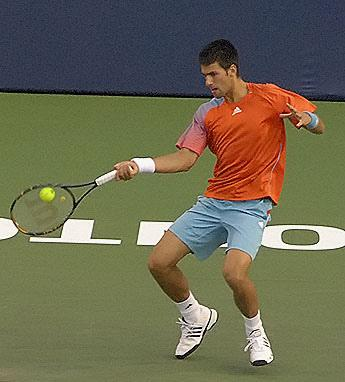Count the number of visible tennis balls and tennis rackets in the picture. There is one tennis ball and one tennis racket visible in the image. What is the color of the tennis ball shown in the picture, and what is its current action? The tennis ball is neon green or yellow-green and is in midair, being hit by the racket. Analyze the interaction between the man and the tennis racket in the image. The man is holding the tennis racket with his right hand and hitting the tennis ball, showing a strong coordination between the man and the racket. Provide a description of the tennis player's outfit and accessories. The tennis player is wearing an orange shirt, light blue shorts, white socks, and white shoes with black markings. He has a white wristband on his right hand and a light blue wristband on his left hand. Refer to the location where the tennis player is playing and describe its primary characteristics. The tennis player is on a green and white tennis court with white letters on the ground and a blue wall in the background. Identify the primary activity depicted in the image. A tennis player swinging a racket to hit a tennis ball. Can you describe the tennis racket held by the leading character in the photo? It is a black and golden tennis racket with a white handle and a "W" visible in the strings. Evaluate the image sentiment based on the objects and actions present. The image sentiment seems focused, energetic, and competitive, as it features a tennis player in action. In this image, what color is the man's shirt, and what is he wearing on his hands? The man is wearing an orange shirt, a white wristband on his right hand, and a light blue wristband on his left hand. Mention the type of shoes the man is wearing and describe their appearance. The man wears white shoes with black markings and black stripes on the side. 